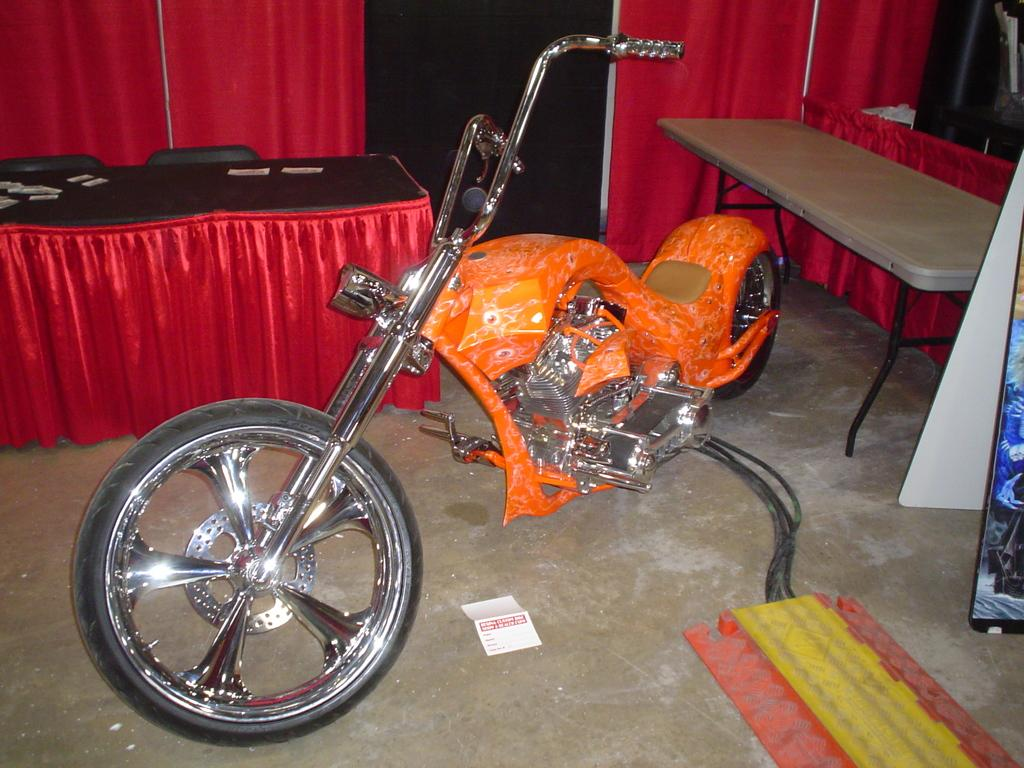What is the main subject of the image? The main subject of the image is a bike. What color is the bike? The bike is orange in color. Are there any other objects or features visible in the image besides the bike? Yes, there are other objects beside the bike. How many women are present on the farm in the image? There is no farm or women present in the image; it features a bike. What type of metal is the bike made of? The facts provided do not specify the type of metal used to make the bike, so we cannot determine that information from the image. 